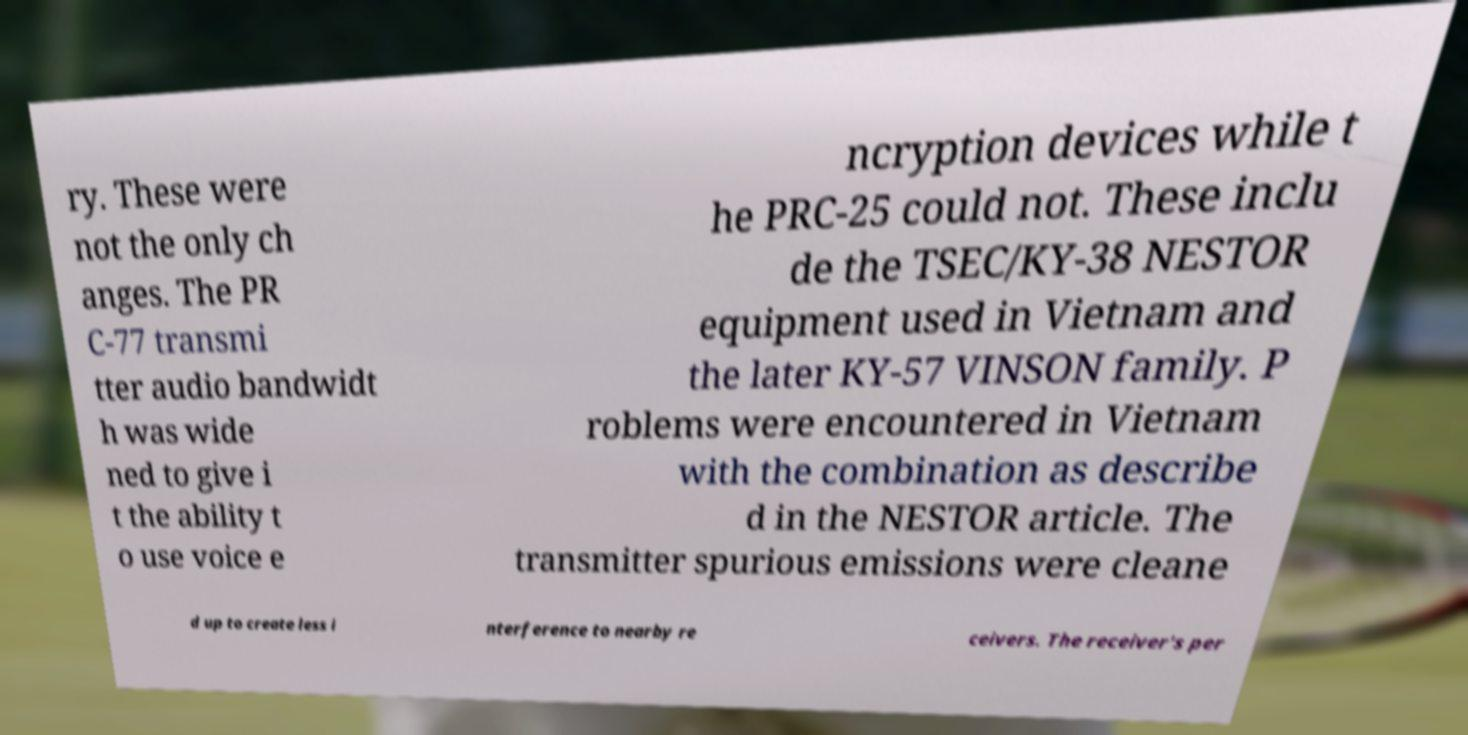Please read and relay the text visible in this image. What does it say? ry. These were not the only ch anges. The PR C-77 transmi tter audio bandwidt h was wide ned to give i t the ability t o use voice e ncryption devices while t he PRC-25 could not. These inclu de the TSEC/KY-38 NESTOR equipment used in Vietnam and the later KY-57 VINSON family. P roblems were encountered in Vietnam with the combination as describe d in the NESTOR article. The transmitter spurious emissions were cleane d up to create less i nterference to nearby re ceivers. The receiver's per 